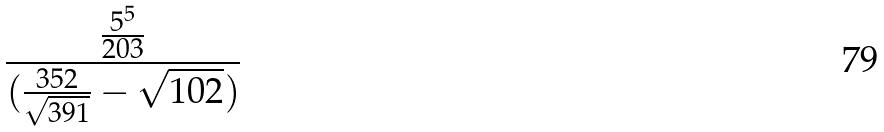<formula> <loc_0><loc_0><loc_500><loc_500>\frac { \frac { 5 ^ { 5 } } { 2 0 3 } } { ( \frac { 3 5 2 } { \sqrt { 3 9 1 } } - \sqrt { 1 0 2 } ) }</formula> 